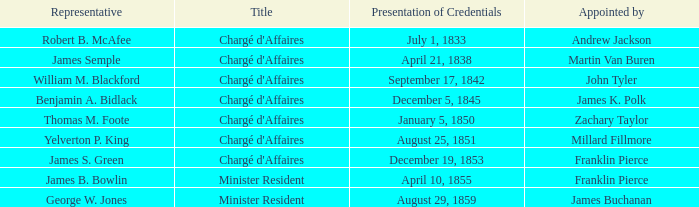Parse the table in full. {'header': ['Representative', 'Title', 'Presentation of Credentials', 'Appointed by'], 'rows': [['Robert B. McAfee', "Chargé d'Affaires", 'July 1, 1833', 'Andrew Jackson'], ['James Semple', "Chargé d'Affaires", 'April 21, 1838', 'Martin Van Buren'], ['William M. Blackford', "Chargé d'Affaires", 'September 17, 1842', 'John Tyler'], ['Benjamin A. Bidlack', "Chargé d'Affaires", 'December 5, 1845', 'James K. Polk'], ['Thomas M. Foote', "Chargé d'Affaires", 'January 5, 1850', 'Zachary Taylor'], ['Yelverton P. King', "Chargé d'Affaires", 'August 25, 1851', 'Millard Fillmore'], ['James S. Green', "Chargé d'Affaires", 'December 19, 1853', 'Franklin Pierce'], ['James B. Bowlin', 'Minister Resident', 'April 10, 1855', 'Franklin Pierce'], ['George W. Jones', 'Minister Resident', 'August 29, 1859', 'James Buchanan']]} What is the mission termination mentioned that includes a presentation of credentials on august 29, 1859? November 4, 1861. 